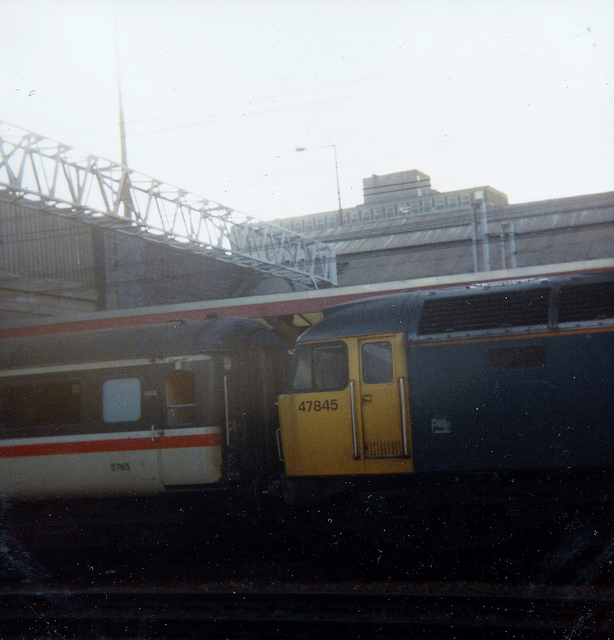Please transcribe the text in this image. 47845 